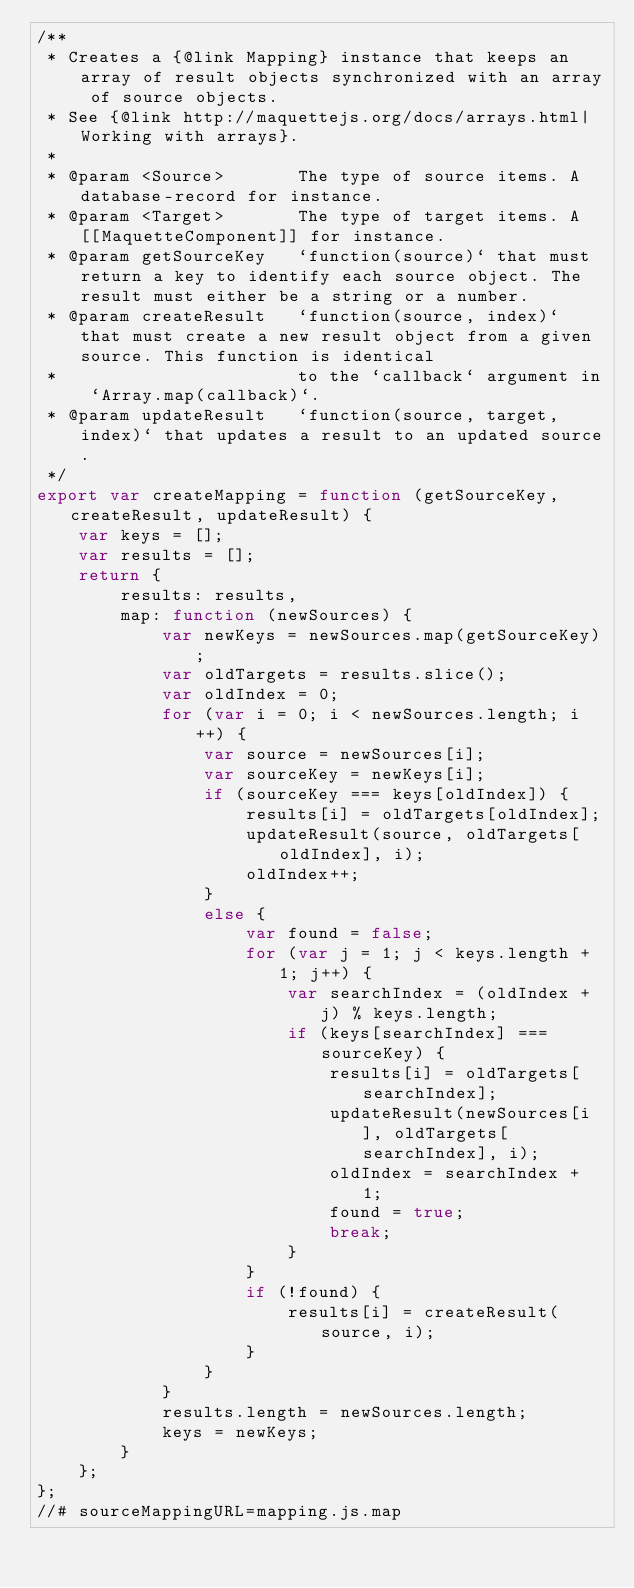<code> <loc_0><loc_0><loc_500><loc_500><_JavaScript_>/**
 * Creates a {@link Mapping} instance that keeps an array of result objects synchronized with an array of source objects.
 * See {@link http://maquettejs.org/docs/arrays.html|Working with arrays}.
 *
 * @param <Source>       The type of source items. A database-record for instance.
 * @param <Target>       The type of target items. A [[MaquetteComponent]] for instance.
 * @param getSourceKey   `function(source)` that must return a key to identify each source object. The result must either be a string or a number.
 * @param createResult   `function(source, index)` that must create a new result object from a given source. This function is identical
 *                       to the `callback` argument in `Array.map(callback)`.
 * @param updateResult   `function(source, target, index)` that updates a result to an updated source.
 */
export var createMapping = function (getSourceKey, createResult, updateResult) {
    var keys = [];
    var results = [];
    return {
        results: results,
        map: function (newSources) {
            var newKeys = newSources.map(getSourceKey);
            var oldTargets = results.slice();
            var oldIndex = 0;
            for (var i = 0; i < newSources.length; i++) {
                var source = newSources[i];
                var sourceKey = newKeys[i];
                if (sourceKey === keys[oldIndex]) {
                    results[i] = oldTargets[oldIndex];
                    updateResult(source, oldTargets[oldIndex], i);
                    oldIndex++;
                }
                else {
                    var found = false;
                    for (var j = 1; j < keys.length + 1; j++) {
                        var searchIndex = (oldIndex + j) % keys.length;
                        if (keys[searchIndex] === sourceKey) {
                            results[i] = oldTargets[searchIndex];
                            updateResult(newSources[i], oldTargets[searchIndex], i);
                            oldIndex = searchIndex + 1;
                            found = true;
                            break;
                        }
                    }
                    if (!found) {
                        results[i] = createResult(source, i);
                    }
                }
            }
            results.length = newSources.length;
            keys = newKeys;
        }
    };
};
//# sourceMappingURL=mapping.js.map</code> 